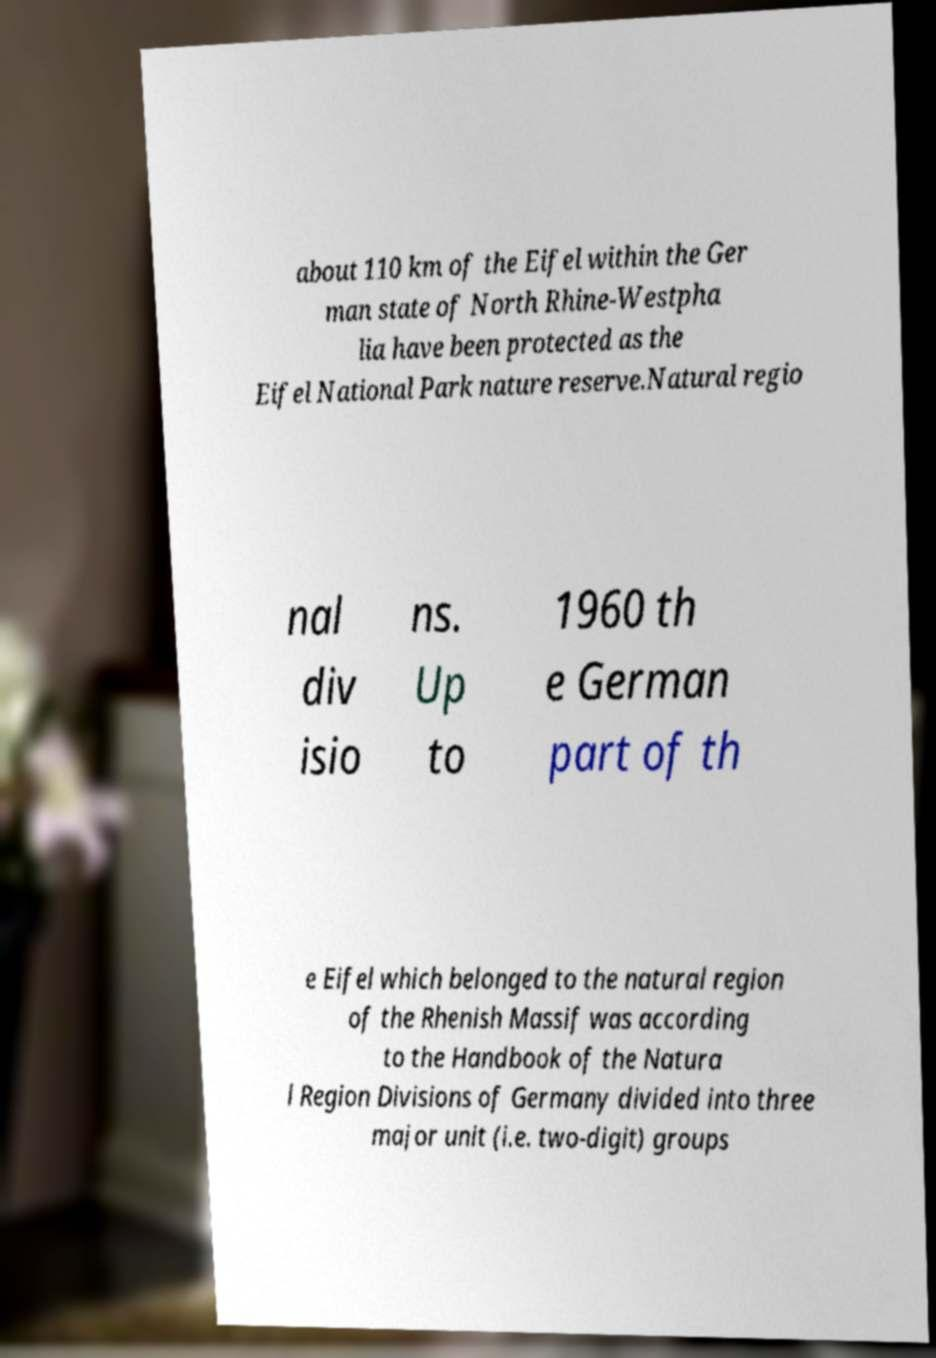I need the written content from this picture converted into text. Can you do that? about 110 km of the Eifel within the Ger man state of North Rhine-Westpha lia have been protected as the Eifel National Park nature reserve.Natural regio nal div isio ns. Up to 1960 th e German part of th e Eifel which belonged to the natural region of the Rhenish Massif was according to the Handbook of the Natura l Region Divisions of Germany divided into three major unit (i.e. two-digit) groups 